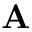Convert formula to latex. <formula><loc_0><loc_0><loc_500><loc_500>A</formula> 